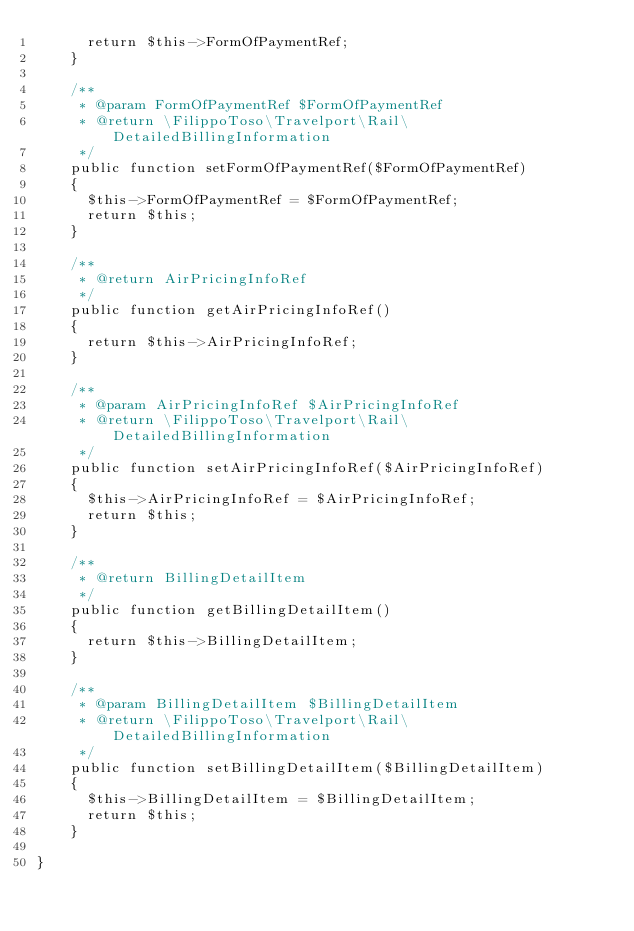Convert code to text. <code><loc_0><loc_0><loc_500><loc_500><_PHP_>      return $this->FormOfPaymentRef;
    }

    /**
     * @param FormOfPaymentRef $FormOfPaymentRef
     * @return \FilippoToso\Travelport\Rail\DetailedBillingInformation
     */
    public function setFormOfPaymentRef($FormOfPaymentRef)
    {
      $this->FormOfPaymentRef = $FormOfPaymentRef;
      return $this;
    }

    /**
     * @return AirPricingInfoRef
     */
    public function getAirPricingInfoRef()
    {
      return $this->AirPricingInfoRef;
    }

    /**
     * @param AirPricingInfoRef $AirPricingInfoRef
     * @return \FilippoToso\Travelport\Rail\DetailedBillingInformation
     */
    public function setAirPricingInfoRef($AirPricingInfoRef)
    {
      $this->AirPricingInfoRef = $AirPricingInfoRef;
      return $this;
    }

    /**
     * @return BillingDetailItem
     */
    public function getBillingDetailItem()
    {
      return $this->BillingDetailItem;
    }

    /**
     * @param BillingDetailItem $BillingDetailItem
     * @return \FilippoToso\Travelport\Rail\DetailedBillingInformation
     */
    public function setBillingDetailItem($BillingDetailItem)
    {
      $this->BillingDetailItem = $BillingDetailItem;
      return $this;
    }

}
</code> 